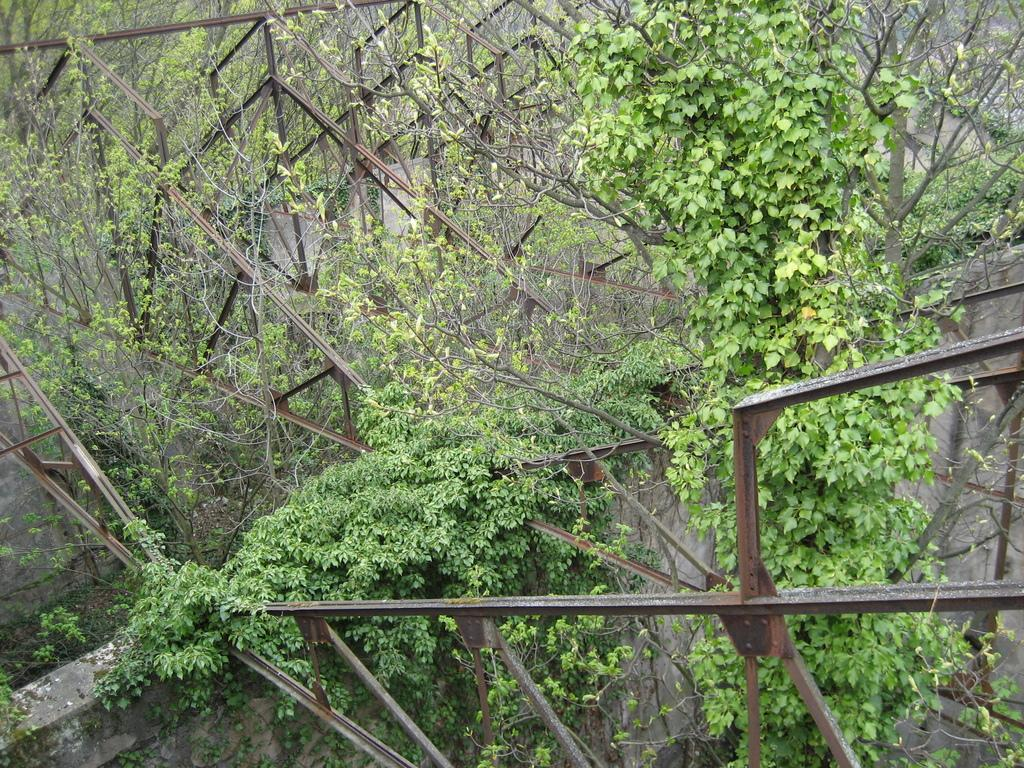What type of structure is visible in the image? There is a stone wall in the image. What material are the rods in the image made of? The rods in the image are made of iron. What type of plant is growing in the image? There are creepers in the image. What can be seen in the background of the image? There are trees visible in the background of the image. What type of sand can be seen in the image? There is no sand present in the image. Can you see any astronauts in the image? There is no reference to space or astronauts in the image. What type of soup is being served in the image? There is no soup present in the image. 